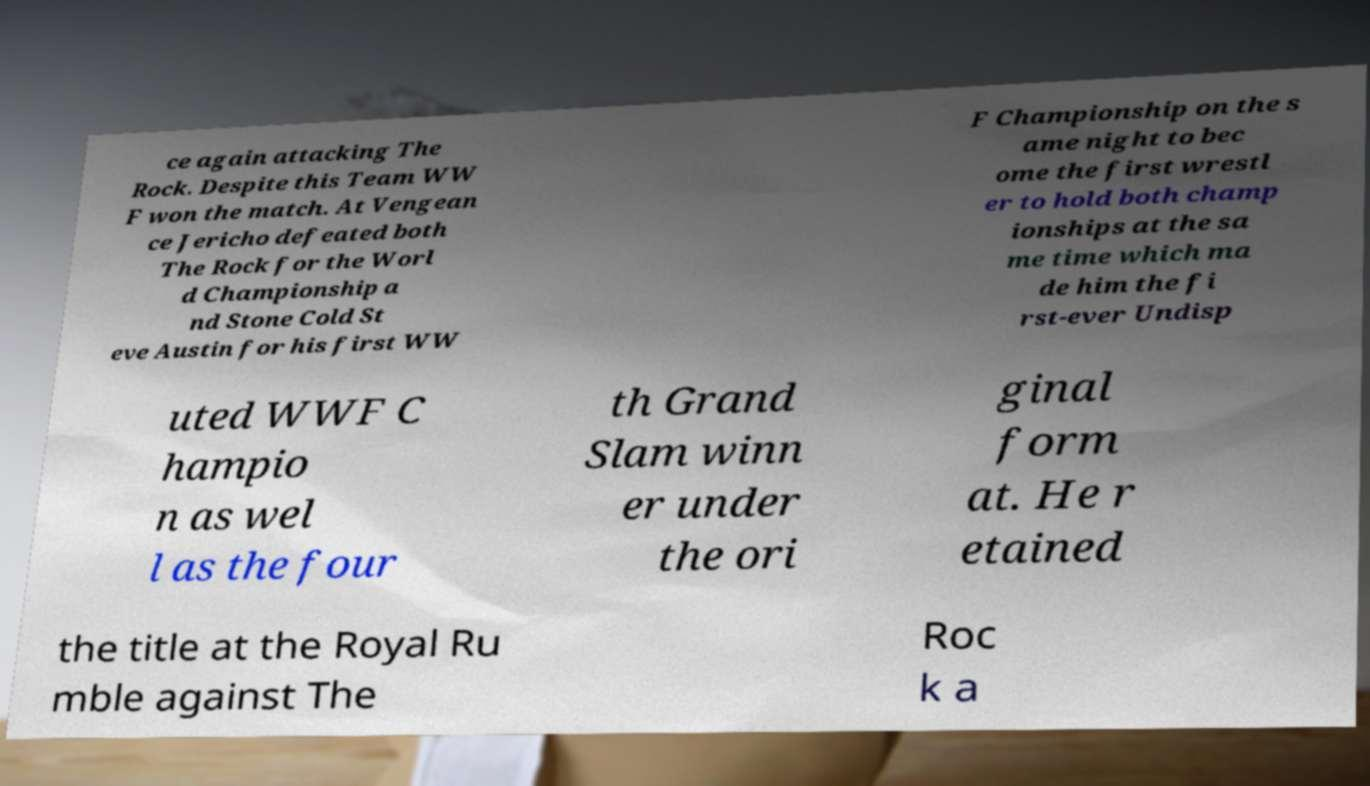What messages or text are displayed in this image? I need them in a readable, typed format. ce again attacking The Rock. Despite this Team WW F won the match. At Vengean ce Jericho defeated both The Rock for the Worl d Championship a nd Stone Cold St eve Austin for his first WW F Championship on the s ame night to bec ome the first wrestl er to hold both champ ionships at the sa me time which ma de him the fi rst-ever Undisp uted WWF C hampio n as wel l as the four th Grand Slam winn er under the ori ginal form at. He r etained the title at the Royal Ru mble against The Roc k a 